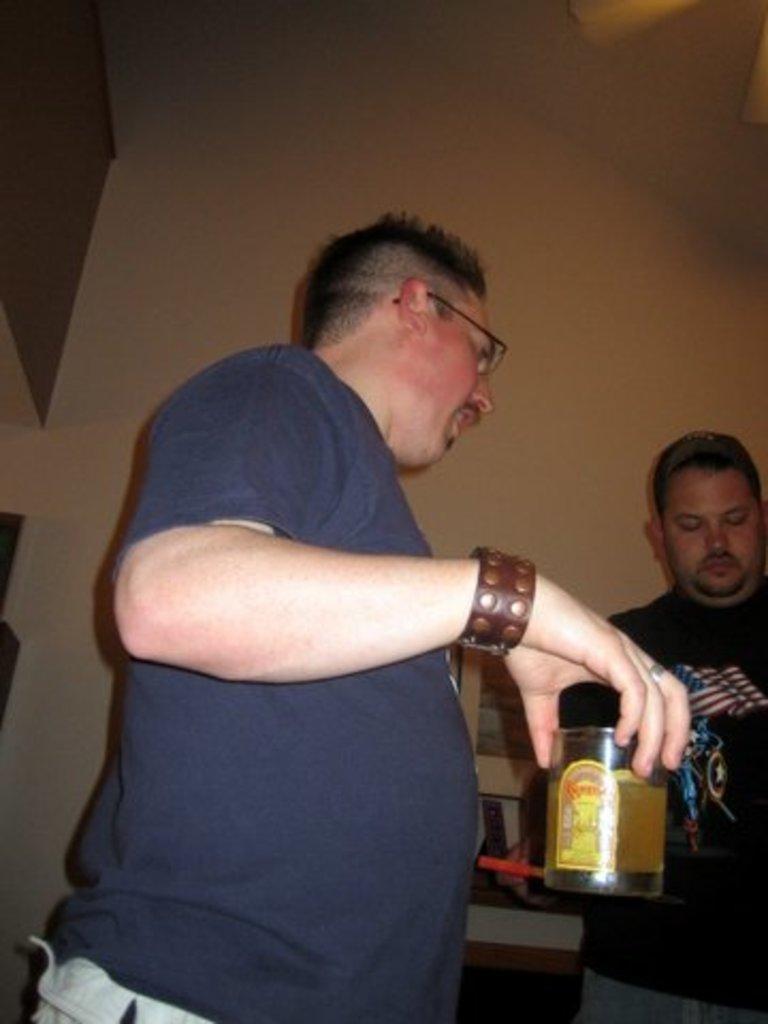In one or two sentences, can you explain what this image depicts? This man is standing and holding a glass with liquid. Beside this person another person is standing and wore black t-shirt. This man wore blue t-shirt and spectacles. 